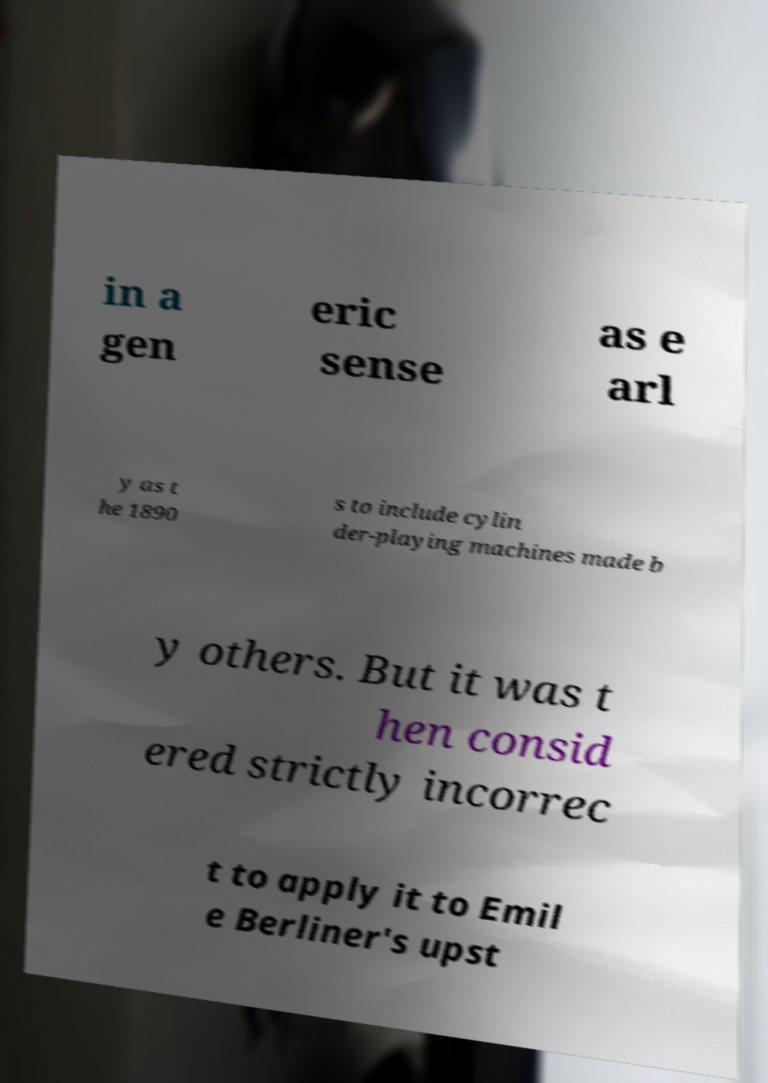For documentation purposes, I need the text within this image transcribed. Could you provide that? in a gen eric sense as e arl y as t he 1890 s to include cylin der-playing machines made b y others. But it was t hen consid ered strictly incorrec t to apply it to Emil e Berliner's upst 